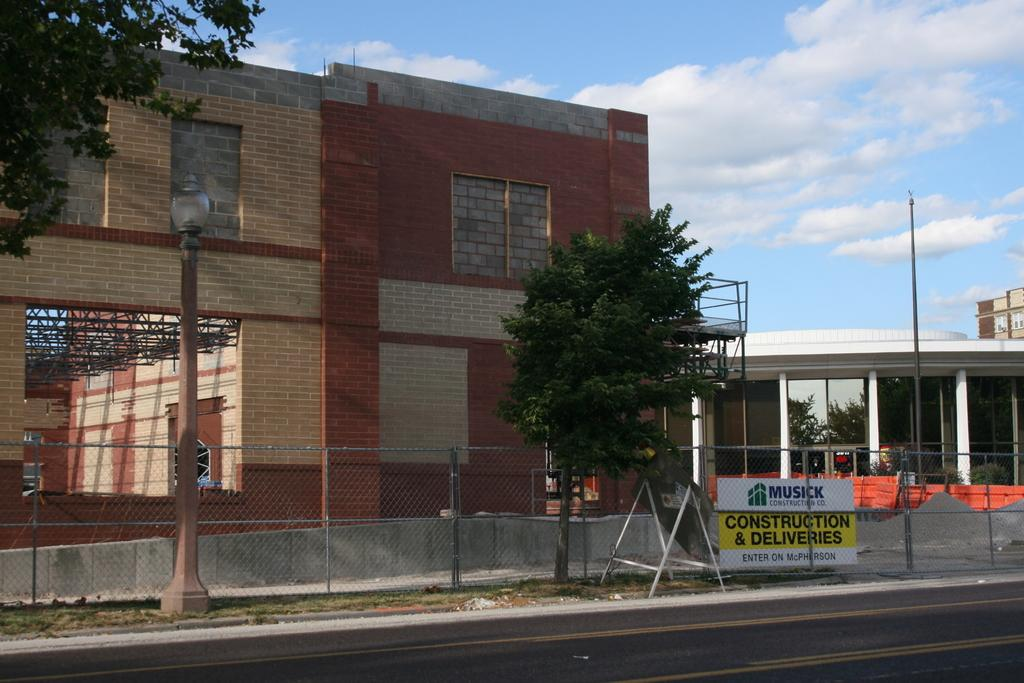What type of structure is visible in the image? There is a building in the image. What can be seen in the surrounding area of the building? There are trees in the area. What is in front of the building to provide security or boundary? There is an iron fencing in front of the building. What is present on the footpath to provide illumination at night? There are street light poles on the footpath. What type of wood is the grandmother using to make a sense of security in the image? There is no grandmother or wood present in the image, and therefore no such activity can be observed. 